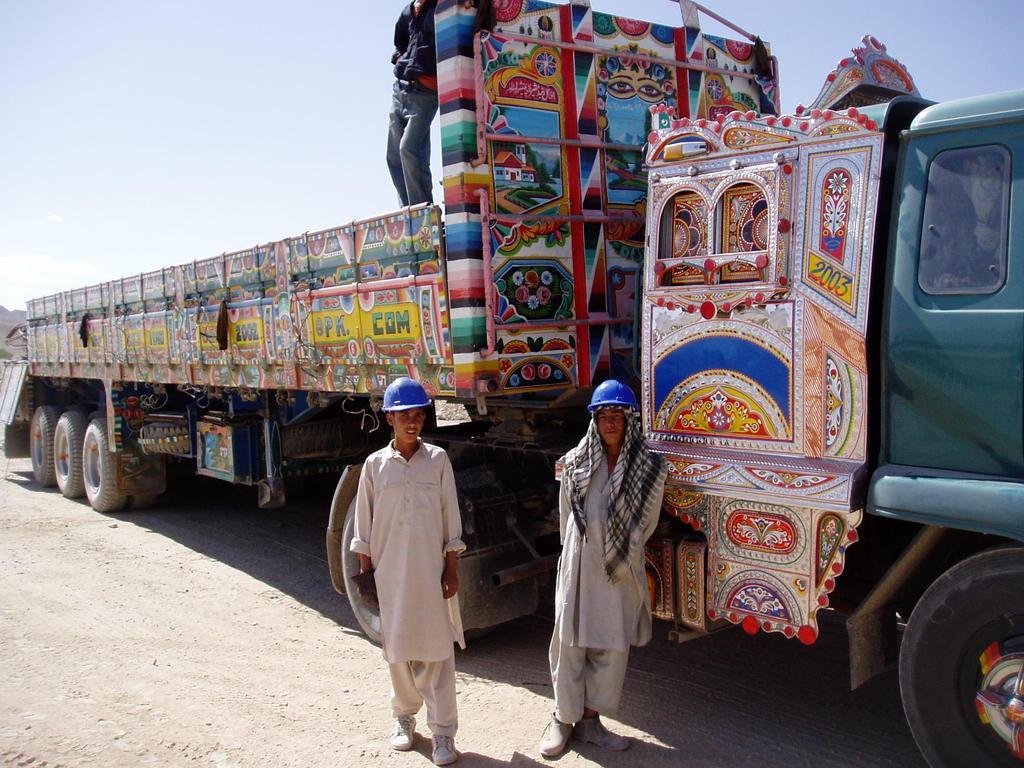In one or two sentences, can you explain what this image depicts? In this image I can see a vehicle. Two people are standing and wearing blue color helmets. The sky is in white color. 